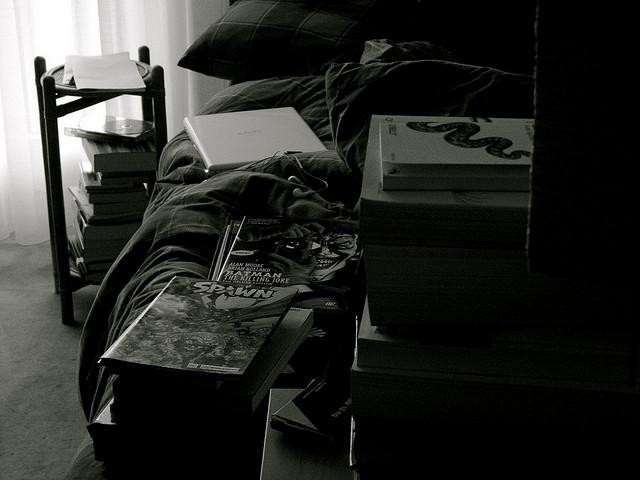What is the name of the comic book in front?
Give a very brief answer. Spawn. Where is this picture taken?
Quick response, please. Bedroom. What type of laptop is on the bed?
Quick response, please. Apple. Is the laptop open or closed?
Answer briefly. Closed. 